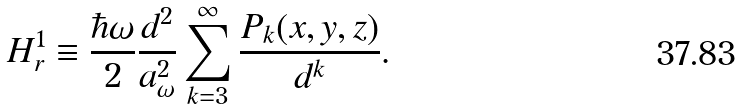<formula> <loc_0><loc_0><loc_500><loc_500>H _ { r } ^ { 1 } \equiv \frac { \hbar { \omega } } 2 \frac { d ^ { 2 } } { a _ { \omega } ^ { 2 } } \sum _ { k = 3 } ^ { \infty } \frac { P _ { k } ( x , y , z ) } { d ^ { k } } .</formula> 